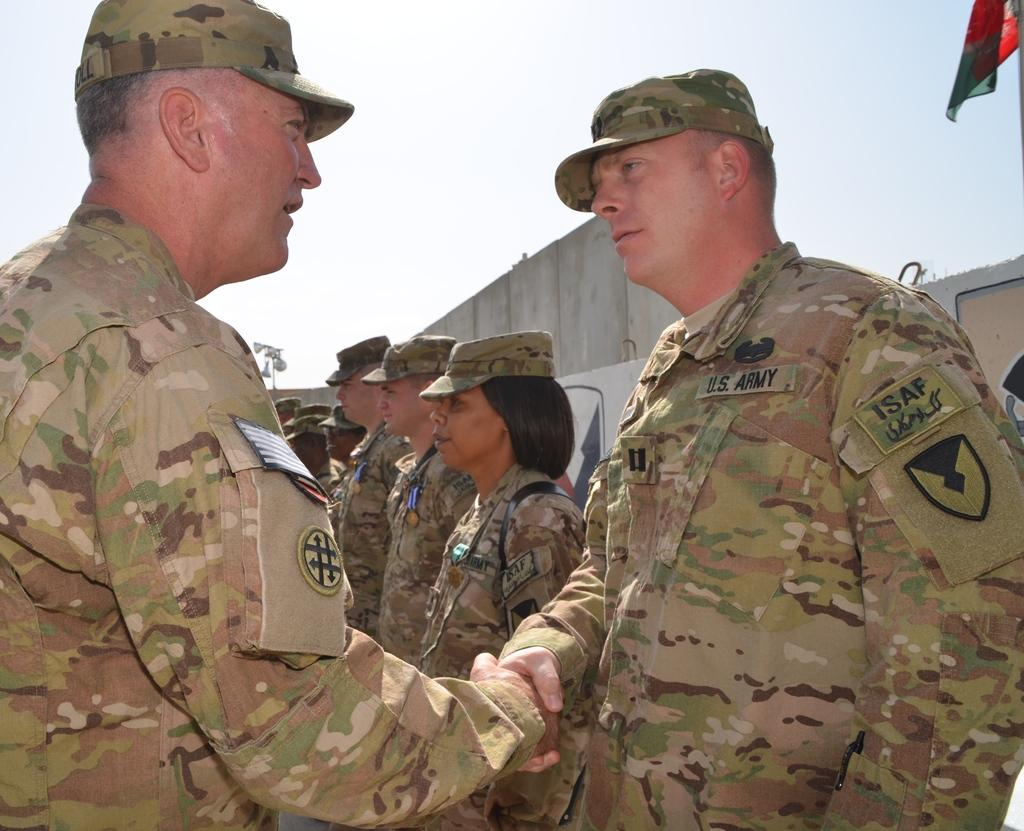What is happening between the people in the image? Two men are shaking hands in the image. How many people are present in the image? There are people standing in the image. What is visible at the top of the image? The sky is visible at the top of the image. What type of rake is being used for air distribution in the image? There is no rake or air distribution system present in the image. 